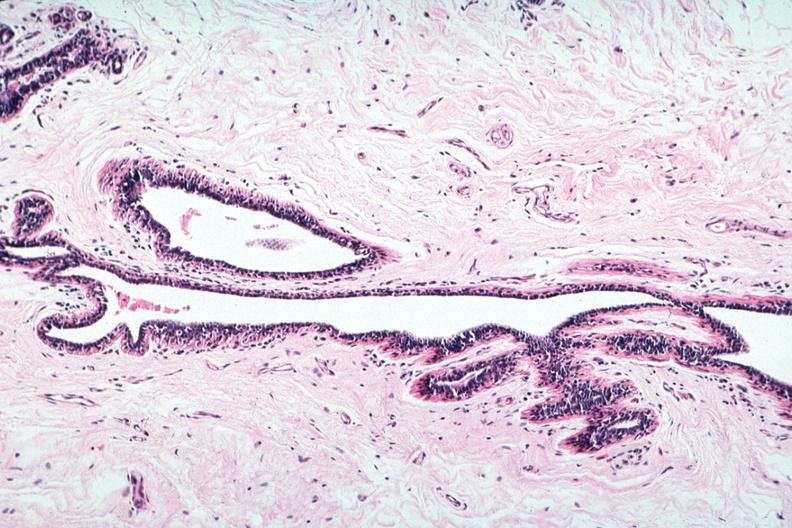s atrophy present?
Answer the question using a single word or phrase. Yes 